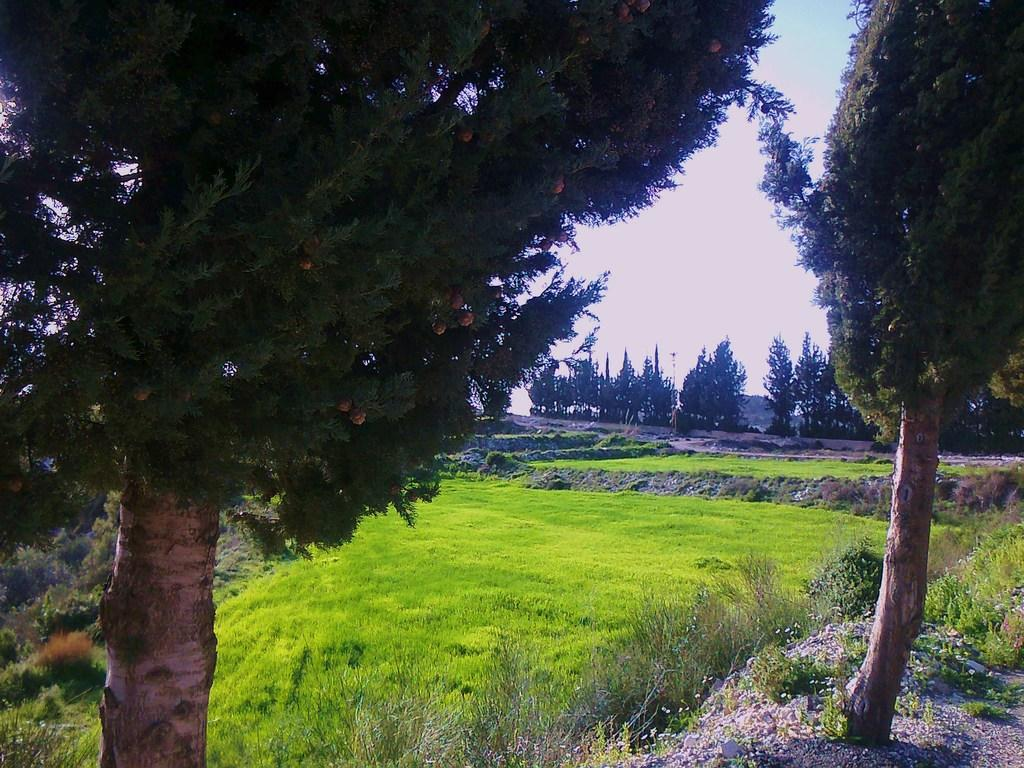What type of vegetation can be seen in the image? There are plants, trees, and grass visible in the image. How many types of vegetation can be seen in the image? There are three types of vegetation: plants, trees, and grass. What is visible in the background of the image? There are more trees, clouds, and the sky visible in the background of the image. What type of loaf is being toasted in the image? There is no loaf or toasting activity present in the image. 